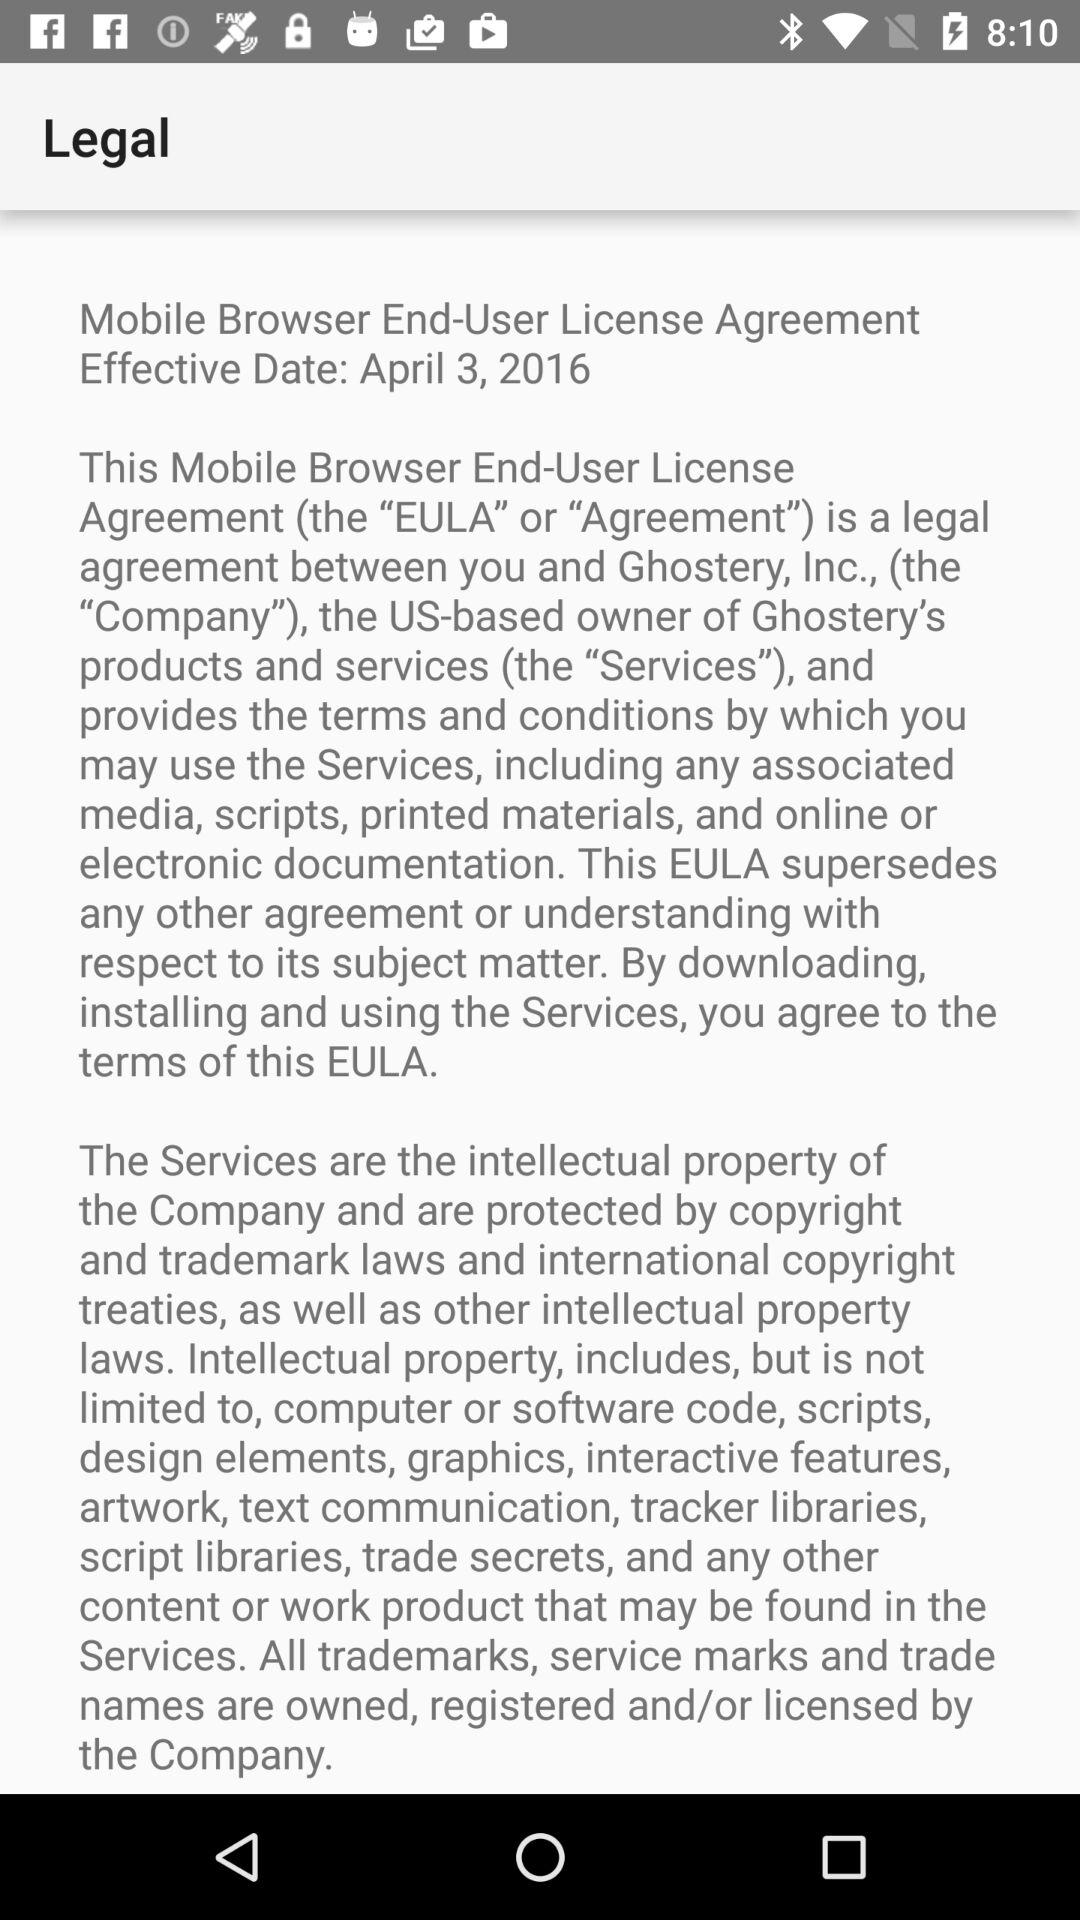What is the mentioned effective date? The mentioned effective date is April 3, 2016. 